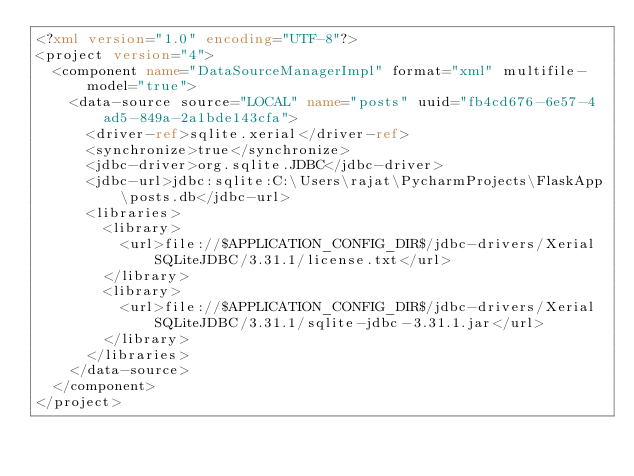<code> <loc_0><loc_0><loc_500><loc_500><_XML_><?xml version="1.0" encoding="UTF-8"?>
<project version="4">
  <component name="DataSourceManagerImpl" format="xml" multifile-model="true">
    <data-source source="LOCAL" name="posts" uuid="fb4cd676-6e57-4ad5-849a-2a1bde143cfa">
      <driver-ref>sqlite.xerial</driver-ref>
      <synchronize>true</synchronize>
      <jdbc-driver>org.sqlite.JDBC</jdbc-driver>
      <jdbc-url>jdbc:sqlite:C:\Users\rajat\PycharmProjects\FlaskApp\posts.db</jdbc-url>
      <libraries>
        <library>
          <url>file://$APPLICATION_CONFIG_DIR$/jdbc-drivers/Xerial SQLiteJDBC/3.31.1/license.txt</url>
        </library>
        <library>
          <url>file://$APPLICATION_CONFIG_DIR$/jdbc-drivers/Xerial SQLiteJDBC/3.31.1/sqlite-jdbc-3.31.1.jar</url>
        </library>
      </libraries>
    </data-source>
  </component>
</project></code> 